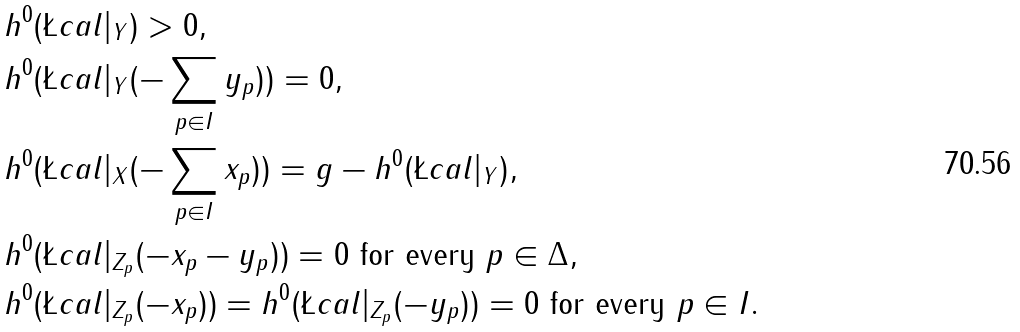Convert formula to latex. <formula><loc_0><loc_0><loc_500><loc_500>& h ^ { 0 } ( \L c a l | _ { Y } ) > 0 , \\ & h ^ { 0 } ( \L c a l | _ { Y } ( - \sum _ { p \in I } y _ { p } ) ) = 0 , \\ & h ^ { 0 } ( \L c a l | _ { X } ( - \sum _ { p \in I } x _ { p } ) ) = g - h ^ { 0 } ( \L c a l | _ { Y } ) , \\ & h ^ { 0 } ( \L c a l | _ { Z _ { p } } ( - x _ { p } - y _ { p } ) ) = 0 \text { for every } p \in \Delta , \\ & h ^ { 0 } ( \L c a l | _ { Z _ { p } } ( - x _ { p } ) ) = h ^ { 0 } ( \L c a l | _ { Z _ { p } } ( - y _ { p } ) ) = 0 \text { for every } p \in I .</formula> 